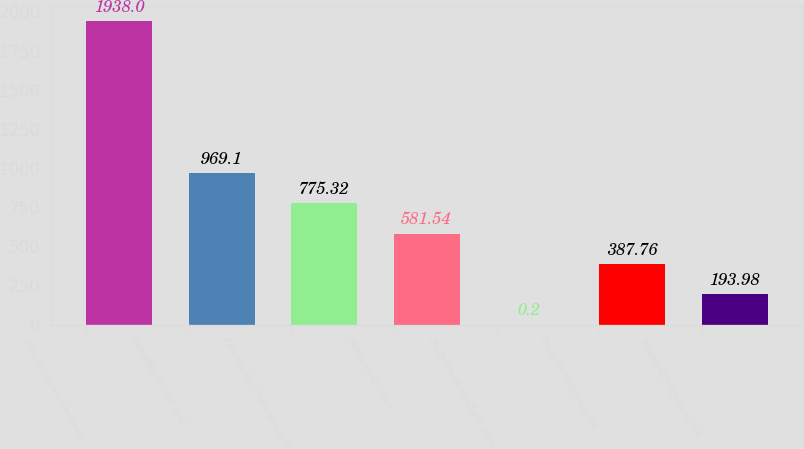Convert chart. <chart><loc_0><loc_0><loc_500><loc_500><bar_chart><fcel>Sales and service revenues<fcel>Operating income (loss)<fcel>Earnings (loss) before income<fcel>Net earnings (loss)<fcel>Dividends declared per share<fcel>Basic earnings (loss) per<fcel>Diluted earnings (loss) per<nl><fcel>1938<fcel>969.1<fcel>775.32<fcel>581.54<fcel>0.2<fcel>387.76<fcel>193.98<nl></chart> 